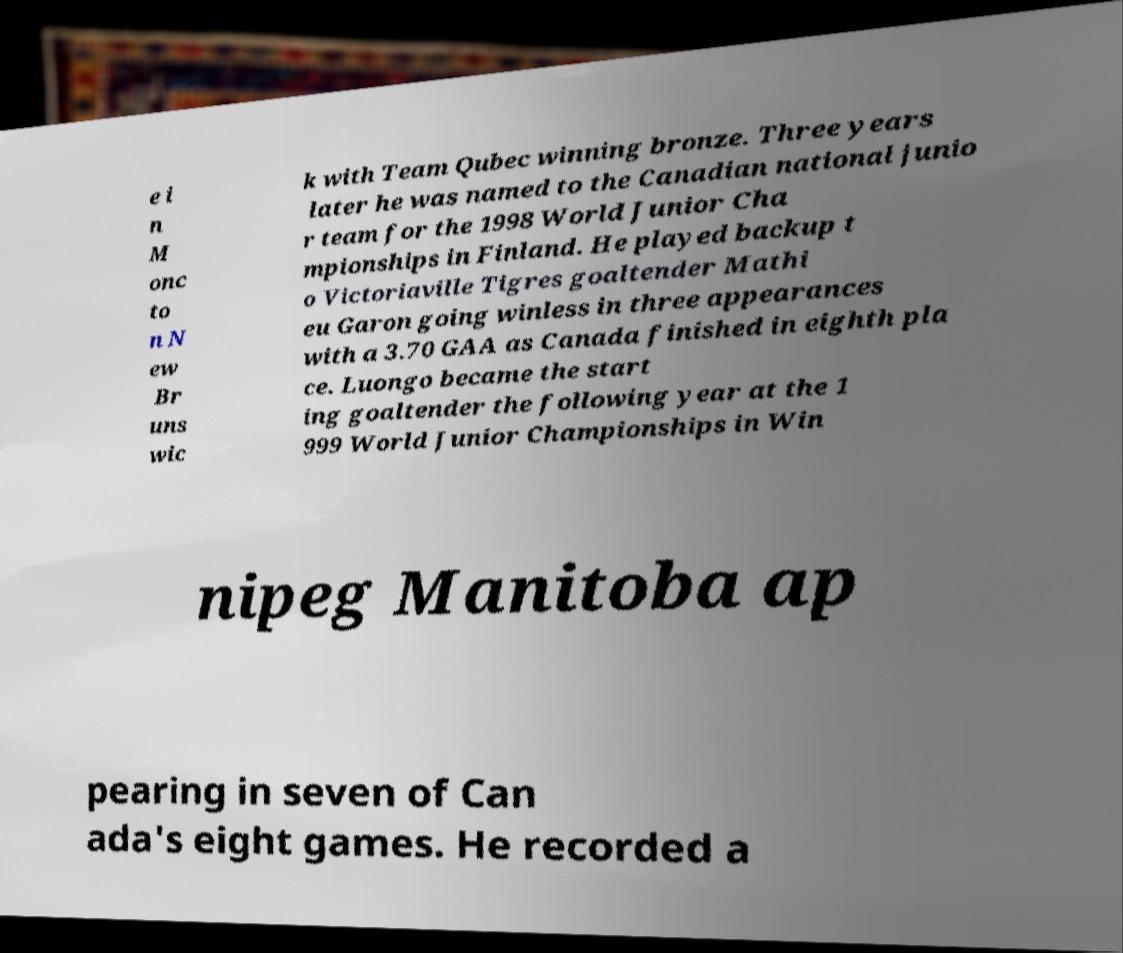For documentation purposes, I need the text within this image transcribed. Could you provide that? e i n M onc to n N ew Br uns wic k with Team Qubec winning bronze. Three years later he was named to the Canadian national junio r team for the 1998 World Junior Cha mpionships in Finland. He played backup t o Victoriaville Tigres goaltender Mathi eu Garon going winless in three appearances with a 3.70 GAA as Canada finished in eighth pla ce. Luongo became the start ing goaltender the following year at the 1 999 World Junior Championships in Win nipeg Manitoba ap pearing in seven of Can ada's eight games. He recorded a 